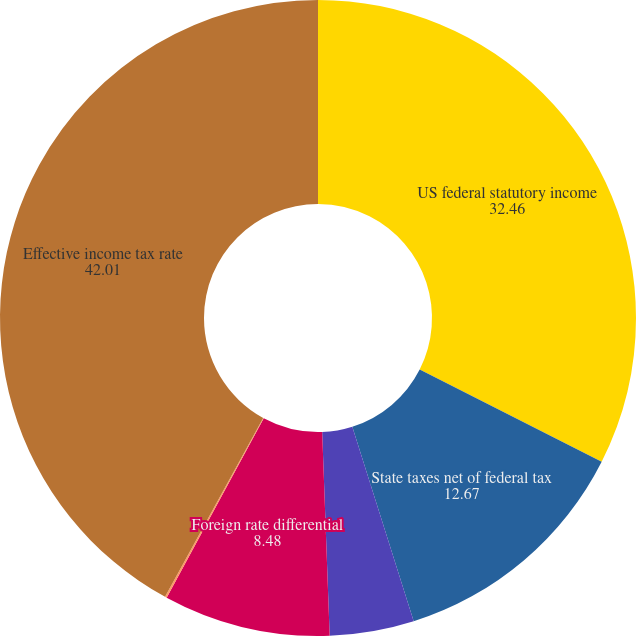Convert chart to OTSL. <chart><loc_0><loc_0><loc_500><loc_500><pie_chart><fcel>US federal statutory income<fcel>State taxes net of federal tax<fcel>Nondeductible expenses<fcel>Foreign rate differential<fcel>Other<fcel>Effective income tax rate<nl><fcel>32.46%<fcel>12.67%<fcel>4.28%<fcel>8.48%<fcel>0.09%<fcel>42.01%<nl></chart> 